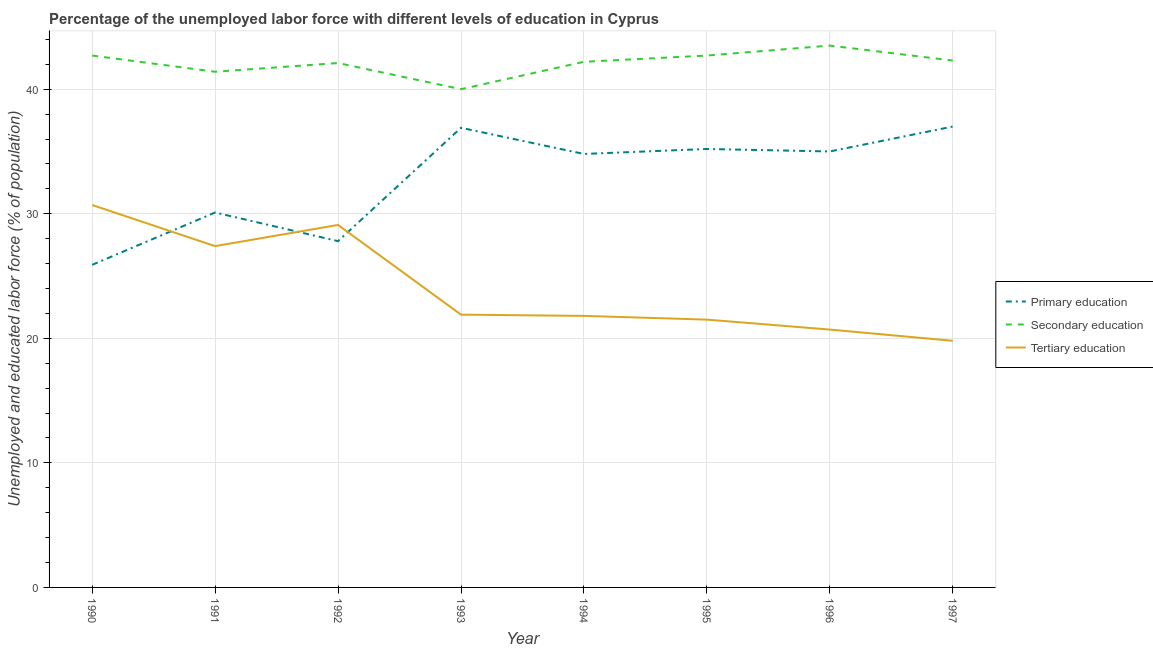Does the line corresponding to percentage of labor force who received primary education intersect with the line corresponding to percentage of labor force who received tertiary education?
Provide a short and direct response. Yes. What is the percentage of labor force who received tertiary education in 1992?
Offer a terse response. 29.1. Across all years, what is the maximum percentage of labor force who received tertiary education?
Your answer should be very brief. 30.7. Across all years, what is the minimum percentage of labor force who received tertiary education?
Provide a short and direct response. 19.8. In which year was the percentage of labor force who received primary education maximum?
Your answer should be compact. 1997. In which year was the percentage of labor force who received secondary education minimum?
Provide a short and direct response. 1993. What is the total percentage of labor force who received secondary education in the graph?
Your response must be concise. 336.9. What is the difference between the percentage of labor force who received primary education in 1993 and that in 1996?
Your answer should be very brief. 1.9. What is the difference between the percentage of labor force who received tertiary education in 1994 and the percentage of labor force who received primary education in 1996?
Offer a very short reply. -13.2. What is the average percentage of labor force who received tertiary education per year?
Provide a short and direct response. 24.11. In the year 1992, what is the difference between the percentage of labor force who received secondary education and percentage of labor force who received tertiary education?
Ensure brevity in your answer.  13. In how many years, is the percentage of labor force who received tertiary education greater than 38 %?
Ensure brevity in your answer.  0. What is the ratio of the percentage of labor force who received secondary education in 1993 to that in 1997?
Offer a terse response. 0.95. Is the difference between the percentage of labor force who received secondary education in 1991 and 1993 greater than the difference between the percentage of labor force who received tertiary education in 1991 and 1993?
Provide a succinct answer. No. What is the difference between the highest and the second highest percentage of labor force who received tertiary education?
Keep it short and to the point. 1.6. What is the difference between the highest and the lowest percentage of labor force who received primary education?
Make the answer very short. 11.1. Is it the case that in every year, the sum of the percentage of labor force who received primary education and percentage of labor force who received secondary education is greater than the percentage of labor force who received tertiary education?
Your answer should be very brief. Yes. Does the percentage of labor force who received primary education monotonically increase over the years?
Keep it short and to the point. No. Is the percentage of labor force who received secondary education strictly less than the percentage of labor force who received primary education over the years?
Your answer should be compact. No. What is the difference between two consecutive major ticks on the Y-axis?
Make the answer very short. 10. Are the values on the major ticks of Y-axis written in scientific E-notation?
Offer a very short reply. No. Does the graph contain any zero values?
Offer a very short reply. No. How many legend labels are there?
Provide a succinct answer. 3. What is the title of the graph?
Your response must be concise. Percentage of the unemployed labor force with different levels of education in Cyprus. Does "Interest" appear as one of the legend labels in the graph?
Give a very brief answer. No. What is the label or title of the Y-axis?
Give a very brief answer. Unemployed and educated labor force (% of population). What is the Unemployed and educated labor force (% of population) of Primary education in 1990?
Keep it short and to the point. 25.9. What is the Unemployed and educated labor force (% of population) of Secondary education in 1990?
Provide a succinct answer. 42.7. What is the Unemployed and educated labor force (% of population) in Tertiary education in 1990?
Ensure brevity in your answer.  30.7. What is the Unemployed and educated labor force (% of population) of Primary education in 1991?
Make the answer very short. 30.1. What is the Unemployed and educated labor force (% of population) of Secondary education in 1991?
Keep it short and to the point. 41.4. What is the Unemployed and educated labor force (% of population) in Tertiary education in 1991?
Offer a very short reply. 27.4. What is the Unemployed and educated labor force (% of population) in Primary education in 1992?
Your answer should be very brief. 27.8. What is the Unemployed and educated labor force (% of population) in Secondary education in 1992?
Provide a succinct answer. 42.1. What is the Unemployed and educated labor force (% of population) of Tertiary education in 1992?
Your answer should be compact. 29.1. What is the Unemployed and educated labor force (% of population) of Primary education in 1993?
Your response must be concise. 36.9. What is the Unemployed and educated labor force (% of population) of Tertiary education in 1993?
Ensure brevity in your answer.  21.9. What is the Unemployed and educated labor force (% of population) in Primary education in 1994?
Offer a terse response. 34.8. What is the Unemployed and educated labor force (% of population) in Secondary education in 1994?
Make the answer very short. 42.2. What is the Unemployed and educated labor force (% of population) of Tertiary education in 1994?
Keep it short and to the point. 21.8. What is the Unemployed and educated labor force (% of population) in Primary education in 1995?
Give a very brief answer. 35.2. What is the Unemployed and educated labor force (% of population) in Secondary education in 1995?
Keep it short and to the point. 42.7. What is the Unemployed and educated labor force (% of population) of Secondary education in 1996?
Ensure brevity in your answer.  43.5. What is the Unemployed and educated labor force (% of population) in Tertiary education in 1996?
Provide a short and direct response. 20.7. What is the Unemployed and educated labor force (% of population) of Secondary education in 1997?
Provide a short and direct response. 42.3. What is the Unemployed and educated labor force (% of population) in Tertiary education in 1997?
Your answer should be very brief. 19.8. Across all years, what is the maximum Unemployed and educated labor force (% of population) of Secondary education?
Offer a very short reply. 43.5. Across all years, what is the maximum Unemployed and educated labor force (% of population) in Tertiary education?
Ensure brevity in your answer.  30.7. Across all years, what is the minimum Unemployed and educated labor force (% of population) of Primary education?
Your answer should be compact. 25.9. Across all years, what is the minimum Unemployed and educated labor force (% of population) of Tertiary education?
Offer a very short reply. 19.8. What is the total Unemployed and educated labor force (% of population) of Primary education in the graph?
Your response must be concise. 262.7. What is the total Unemployed and educated labor force (% of population) in Secondary education in the graph?
Your answer should be compact. 336.9. What is the total Unemployed and educated labor force (% of population) in Tertiary education in the graph?
Keep it short and to the point. 192.9. What is the difference between the Unemployed and educated labor force (% of population) in Secondary education in 1990 and that in 1992?
Offer a terse response. 0.6. What is the difference between the Unemployed and educated labor force (% of population) in Tertiary education in 1990 and that in 1992?
Provide a succinct answer. 1.6. What is the difference between the Unemployed and educated labor force (% of population) in Primary education in 1990 and that in 1995?
Offer a very short reply. -9.3. What is the difference between the Unemployed and educated labor force (% of population) of Primary education in 1990 and that in 1996?
Offer a very short reply. -9.1. What is the difference between the Unemployed and educated labor force (% of population) in Secondary education in 1990 and that in 1996?
Make the answer very short. -0.8. What is the difference between the Unemployed and educated labor force (% of population) in Primary education in 1990 and that in 1997?
Provide a succinct answer. -11.1. What is the difference between the Unemployed and educated labor force (% of population) in Primary education in 1991 and that in 1992?
Ensure brevity in your answer.  2.3. What is the difference between the Unemployed and educated labor force (% of population) in Secondary education in 1991 and that in 1992?
Offer a very short reply. -0.7. What is the difference between the Unemployed and educated labor force (% of population) of Tertiary education in 1991 and that in 1992?
Keep it short and to the point. -1.7. What is the difference between the Unemployed and educated labor force (% of population) in Primary education in 1991 and that in 1993?
Ensure brevity in your answer.  -6.8. What is the difference between the Unemployed and educated labor force (% of population) in Tertiary education in 1991 and that in 1993?
Your answer should be compact. 5.5. What is the difference between the Unemployed and educated labor force (% of population) in Primary education in 1991 and that in 1995?
Give a very brief answer. -5.1. What is the difference between the Unemployed and educated labor force (% of population) in Secondary education in 1991 and that in 1995?
Your answer should be very brief. -1.3. What is the difference between the Unemployed and educated labor force (% of population) in Tertiary education in 1991 and that in 1995?
Keep it short and to the point. 5.9. What is the difference between the Unemployed and educated labor force (% of population) in Tertiary education in 1991 and that in 1996?
Keep it short and to the point. 6.7. What is the difference between the Unemployed and educated labor force (% of population) of Primary education in 1991 and that in 1997?
Provide a short and direct response. -6.9. What is the difference between the Unemployed and educated labor force (% of population) of Tertiary education in 1992 and that in 1993?
Your answer should be compact. 7.2. What is the difference between the Unemployed and educated labor force (% of population) of Primary education in 1992 and that in 1994?
Ensure brevity in your answer.  -7. What is the difference between the Unemployed and educated labor force (% of population) of Secondary education in 1992 and that in 1994?
Your answer should be very brief. -0.1. What is the difference between the Unemployed and educated labor force (% of population) of Tertiary education in 1992 and that in 1994?
Your response must be concise. 7.3. What is the difference between the Unemployed and educated labor force (% of population) of Secondary education in 1992 and that in 1995?
Your response must be concise. -0.6. What is the difference between the Unemployed and educated labor force (% of population) in Tertiary education in 1992 and that in 1995?
Provide a short and direct response. 7.6. What is the difference between the Unemployed and educated labor force (% of population) of Secondary education in 1992 and that in 1996?
Your answer should be compact. -1.4. What is the difference between the Unemployed and educated labor force (% of population) of Primary education in 1992 and that in 1997?
Offer a terse response. -9.2. What is the difference between the Unemployed and educated labor force (% of population) of Secondary education in 1993 and that in 1994?
Offer a terse response. -2.2. What is the difference between the Unemployed and educated labor force (% of population) in Tertiary education in 1993 and that in 1994?
Keep it short and to the point. 0.1. What is the difference between the Unemployed and educated labor force (% of population) in Tertiary education in 1993 and that in 1996?
Provide a short and direct response. 1.2. What is the difference between the Unemployed and educated labor force (% of population) in Tertiary education in 1993 and that in 1997?
Offer a very short reply. 2.1. What is the difference between the Unemployed and educated labor force (% of population) in Primary education in 1994 and that in 1995?
Give a very brief answer. -0.4. What is the difference between the Unemployed and educated labor force (% of population) of Tertiary education in 1994 and that in 1995?
Provide a short and direct response. 0.3. What is the difference between the Unemployed and educated labor force (% of population) of Primary education in 1994 and that in 1997?
Provide a succinct answer. -2.2. What is the difference between the Unemployed and educated labor force (% of population) of Tertiary education in 1994 and that in 1997?
Your answer should be compact. 2. What is the difference between the Unemployed and educated labor force (% of population) in Primary education in 1995 and that in 1996?
Provide a short and direct response. 0.2. What is the difference between the Unemployed and educated labor force (% of population) in Tertiary education in 1995 and that in 1997?
Offer a very short reply. 1.7. What is the difference between the Unemployed and educated labor force (% of population) of Primary education in 1990 and the Unemployed and educated labor force (% of population) of Secondary education in 1991?
Keep it short and to the point. -15.5. What is the difference between the Unemployed and educated labor force (% of population) of Primary education in 1990 and the Unemployed and educated labor force (% of population) of Tertiary education in 1991?
Your response must be concise. -1.5. What is the difference between the Unemployed and educated labor force (% of population) of Primary education in 1990 and the Unemployed and educated labor force (% of population) of Secondary education in 1992?
Give a very brief answer. -16.2. What is the difference between the Unemployed and educated labor force (% of population) of Primary education in 1990 and the Unemployed and educated labor force (% of population) of Tertiary education in 1992?
Keep it short and to the point. -3.2. What is the difference between the Unemployed and educated labor force (% of population) of Secondary education in 1990 and the Unemployed and educated labor force (% of population) of Tertiary education in 1992?
Your answer should be very brief. 13.6. What is the difference between the Unemployed and educated labor force (% of population) of Primary education in 1990 and the Unemployed and educated labor force (% of population) of Secondary education in 1993?
Offer a very short reply. -14.1. What is the difference between the Unemployed and educated labor force (% of population) in Secondary education in 1990 and the Unemployed and educated labor force (% of population) in Tertiary education in 1993?
Your answer should be very brief. 20.8. What is the difference between the Unemployed and educated labor force (% of population) of Primary education in 1990 and the Unemployed and educated labor force (% of population) of Secondary education in 1994?
Your answer should be very brief. -16.3. What is the difference between the Unemployed and educated labor force (% of population) of Secondary education in 1990 and the Unemployed and educated labor force (% of population) of Tertiary education in 1994?
Offer a terse response. 20.9. What is the difference between the Unemployed and educated labor force (% of population) of Primary education in 1990 and the Unemployed and educated labor force (% of population) of Secondary education in 1995?
Give a very brief answer. -16.8. What is the difference between the Unemployed and educated labor force (% of population) in Primary education in 1990 and the Unemployed and educated labor force (% of population) in Tertiary education in 1995?
Keep it short and to the point. 4.4. What is the difference between the Unemployed and educated labor force (% of population) of Secondary education in 1990 and the Unemployed and educated labor force (% of population) of Tertiary education in 1995?
Your answer should be very brief. 21.2. What is the difference between the Unemployed and educated labor force (% of population) of Primary education in 1990 and the Unemployed and educated labor force (% of population) of Secondary education in 1996?
Offer a terse response. -17.6. What is the difference between the Unemployed and educated labor force (% of population) of Primary education in 1990 and the Unemployed and educated labor force (% of population) of Tertiary education in 1996?
Give a very brief answer. 5.2. What is the difference between the Unemployed and educated labor force (% of population) of Secondary education in 1990 and the Unemployed and educated labor force (% of population) of Tertiary education in 1996?
Provide a short and direct response. 22. What is the difference between the Unemployed and educated labor force (% of population) of Primary education in 1990 and the Unemployed and educated labor force (% of population) of Secondary education in 1997?
Keep it short and to the point. -16.4. What is the difference between the Unemployed and educated labor force (% of population) in Primary education in 1990 and the Unemployed and educated labor force (% of population) in Tertiary education in 1997?
Keep it short and to the point. 6.1. What is the difference between the Unemployed and educated labor force (% of population) in Secondary education in 1990 and the Unemployed and educated labor force (% of population) in Tertiary education in 1997?
Provide a short and direct response. 22.9. What is the difference between the Unemployed and educated labor force (% of population) in Primary education in 1991 and the Unemployed and educated labor force (% of population) in Secondary education in 1993?
Your answer should be compact. -9.9. What is the difference between the Unemployed and educated labor force (% of population) of Secondary education in 1991 and the Unemployed and educated labor force (% of population) of Tertiary education in 1993?
Make the answer very short. 19.5. What is the difference between the Unemployed and educated labor force (% of population) of Secondary education in 1991 and the Unemployed and educated labor force (% of population) of Tertiary education in 1994?
Ensure brevity in your answer.  19.6. What is the difference between the Unemployed and educated labor force (% of population) in Primary education in 1991 and the Unemployed and educated labor force (% of population) in Tertiary education in 1995?
Provide a succinct answer. 8.6. What is the difference between the Unemployed and educated labor force (% of population) of Secondary education in 1991 and the Unemployed and educated labor force (% of population) of Tertiary education in 1995?
Your response must be concise. 19.9. What is the difference between the Unemployed and educated labor force (% of population) in Primary education in 1991 and the Unemployed and educated labor force (% of population) in Tertiary education in 1996?
Provide a short and direct response. 9.4. What is the difference between the Unemployed and educated labor force (% of population) of Secondary education in 1991 and the Unemployed and educated labor force (% of population) of Tertiary education in 1996?
Keep it short and to the point. 20.7. What is the difference between the Unemployed and educated labor force (% of population) of Primary education in 1991 and the Unemployed and educated labor force (% of population) of Tertiary education in 1997?
Offer a very short reply. 10.3. What is the difference between the Unemployed and educated labor force (% of population) in Secondary education in 1991 and the Unemployed and educated labor force (% of population) in Tertiary education in 1997?
Your response must be concise. 21.6. What is the difference between the Unemployed and educated labor force (% of population) of Primary education in 1992 and the Unemployed and educated labor force (% of population) of Tertiary education in 1993?
Provide a succinct answer. 5.9. What is the difference between the Unemployed and educated labor force (% of population) in Secondary education in 1992 and the Unemployed and educated labor force (% of population) in Tertiary education in 1993?
Your response must be concise. 20.2. What is the difference between the Unemployed and educated labor force (% of population) in Primary education in 1992 and the Unemployed and educated labor force (% of population) in Secondary education in 1994?
Give a very brief answer. -14.4. What is the difference between the Unemployed and educated labor force (% of population) of Secondary education in 1992 and the Unemployed and educated labor force (% of population) of Tertiary education in 1994?
Provide a short and direct response. 20.3. What is the difference between the Unemployed and educated labor force (% of population) of Primary education in 1992 and the Unemployed and educated labor force (% of population) of Secondary education in 1995?
Give a very brief answer. -14.9. What is the difference between the Unemployed and educated labor force (% of population) of Primary education in 1992 and the Unemployed and educated labor force (% of population) of Tertiary education in 1995?
Your answer should be very brief. 6.3. What is the difference between the Unemployed and educated labor force (% of population) of Secondary education in 1992 and the Unemployed and educated labor force (% of population) of Tertiary education in 1995?
Offer a very short reply. 20.6. What is the difference between the Unemployed and educated labor force (% of population) in Primary education in 1992 and the Unemployed and educated labor force (% of population) in Secondary education in 1996?
Give a very brief answer. -15.7. What is the difference between the Unemployed and educated labor force (% of population) in Primary education in 1992 and the Unemployed and educated labor force (% of population) in Tertiary education in 1996?
Ensure brevity in your answer.  7.1. What is the difference between the Unemployed and educated labor force (% of population) in Secondary education in 1992 and the Unemployed and educated labor force (% of population) in Tertiary education in 1996?
Ensure brevity in your answer.  21.4. What is the difference between the Unemployed and educated labor force (% of population) of Primary education in 1992 and the Unemployed and educated labor force (% of population) of Tertiary education in 1997?
Keep it short and to the point. 8. What is the difference between the Unemployed and educated labor force (% of population) in Secondary education in 1992 and the Unemployed and educated labor force (% of population) in Tertiary education in 1997?
Keep it short and to the point. 22.3. What is the difference between the Unemployed and educated labor force (% of population) in Primary education in 1993 and the Unemployed and educated labor force (% of population) in Secondary education in 1994?
Give a very brief answer. -5.3. What is the difference between the Unemployed and educated labor force (% of population) of Secondary education in 1993 and the Unemployed and educated labor force (% of population) of Tertiary education in 1994?
Keep it short and to the point. 18.2. What is the difference between the Unemployed and educated labor force (% of population) in Primary education in 1993 and the Unemployed and educated labor force (% of population) in Tertiary education in 1996?
Your response must be concise. 16.2. What is the difference between the Unemployed and educated labor force (% of population) in Secondary education in 1993 and the Unemployed and educated labor force (% of population) in Tertiary education in 1996?
Ensure brevity in your answer.  19.3. What is the difference between the Unemployed and educated labor force (% of population) of Primary education in 1993 and the Unemployed and educated labor force (% of population) of Secondary education in 1997?
Offer a very short reply. -5.4. What is the difference between the Unemployed and educated labor force (% of population) in Primary education in 1993 and the Unemployed and educated labor force (% of population) in Tertiary education in 1997?
Give a very brief answer. 17.1. What is the difference between the Unemployed and educated labor force (% of population) of Secondary education in 1993 and the Unemployed and educated labor force (% of population) of Tertiary education in 1997?
Provide a succinct answer. 20.2. What is the difference between the Unemployed and educated labor force (% of population) of Secondary education in 1994 and the Unemployed and educated labor force (% of population) of Tertiary education in 1995?
Give a very brief answer. 20.7. What is the difference between the Unemployed and educated labor force (% of population) of Primary education in 1994 and the Unemployed and educated labor force (% of population) of Secondary education in 1997?
Provide a succinct answer. -7.5. What is the difference between the Unemployed and educated labor force (% of population) in Primary education in 1994 and the Unemployed and educated labor force (% of population) in Tertiary education in 1997?
Give a very brief answer. 15. What is the difference between the Unemployed and educated labor force (% of population) of Secondary education in 1994 and the Unemployed and educated labor force (% of population) of Tertiary education in 1997?
Your response must be concise. 22.4. What is the difference between the Unemployed and educated labor force (% of population) of Primary education in 1995 and the Unemployed and educated labor force (% of population) of Secondary education in 1996?
Your response must be concise. -8.3. What is the difference between the Unemployed and educated labor force (% of population) in Secondary education in 1995 and the Unemployed and educated labor force (% of population) in Tertiary education in 1996?
Keep it short and to the point. 22. What is the difference between the Unemployed and educated labor force (% of population) in Primary education in 1995 and the Unemployed and educated labor force (% of population) in Tertiary education in 1997?
Give a very brief answer. 15.4. What is the difference between the Unemployed and educated labor force (% of population) of Secondary education in 1995 and the Unemployed and educated labor force (% of population) of Tertiary education in 1997?
Your answer should be compact. 22.9. What is the difference between the Unemployed and educated labor force (% of population) of Primary education in 1996 and the Unemployed and educated labor force (% of population) of Secondary education in 1997?
Offer a terse response. -7.3. What is the difference between the Unemployed and educated labor force (% of population) of Primary education in 1996 and the Unemployed and educated labor force (% of population) of Tertiary education in 1997?
Provide a short and direct response. 15.2. What is the difference between the Unemployed and educated labor force (% of population) of Secondary education in 1996 and the Unemployed and educated labor force (% of population) of Tertiary education in 1997?
Make the answer very short. 23.7. What is the average Unemployed and educated labor force (% of population) in Primary education per year?
Offer a terse response. 32.84. What is the average Unemployed and educated labor force (% of population) of Secondary education per year?
Provide a short and direct response. 42.11. What is the average Unemployed and educated labor force (% of population) in Tertiary education per year?
Your answer should be very brief. 24.11. In the year 1990, what is the difference between the Unemployed and educated labor force (% of population) in Primary education and Unemployed and educated labor force (% of population) in Secondary education?
Provide a succinct answer. -16.8. In the year 1991, what is the difference between the Unemployed and educated labor force (% of population) in Primary education and Unemployed and educated labor force (% of population) in Secondary education?
Provide a succinct answer. -11.3. In the year 1991, what is the difference between the Unemployed and educated labor force (% of population) of Primary education and Unemployed and educated labor force (% of population) of Tertiary education?
Your response must be concise. 2.7. In the year 1991, what is the difference between the Unemployed and educated labor force (% of population) in Secondary education and Unemployed and educated labor force (% of population) in Tertiary education?
Make the answer very short. 14. In the year 1992, what is the difference between the Unemployed and educated labor force (% of population) in Primary education and Unemployed and educated labor force (% of population) in Secondary education?
Make the answer very short. -14.3. In the year 1992, what is the difference between the Unemployed and educated labor force (% of population) in Secondary education and Unemployed and educated labor force (% of population) in Tertiary education?
Your answer should be very brief. 13. In the year 1994, what is the difference between the Unemployed and educated labor force (% of population) in Primary education and Unemployed and educated labor force (% of population) in Tertiary education?
Offer a terse response. 13. In the year 1994, what is the difference between the Unemployed and educated labor force (% of population) in Secondary education and Unemployed and educated labor force (% of population) in Tertiary education?
Provide a short and direct response. 20.4. In the year 1995, what is the difference between the Unemployed and educated labor force (% of population) in Primary education and Unemployed and educated labor force (% of population) in Tertiary education?
Offer a very short reply. 13.7. In the year 1995, what is the difference between the Unemployed and educated labor force (% of population) of Secondary education and Unemployed and educated labor force (% of population) of Tertiary education?
Provide a short and direct response. 21.2. In the year 1996, what is the difference between the Unemployed and educated labor force (% of population) in Primary education and Unemployed and educated labor force (% of population) in Tertiary education?
Ensure brevity in your answer.  14.3. In the year 1996, what is the difference between the Unemployed and educated labor force (% of population) in Secondary education and Unemployed and educated labor force (% of population) in Tertiary education?
Your answer should be very brief. 22.8. In the year 1997, what is the difference between the Unemployed and educated labor force (% of population) in Primary education and Unemployed and educated labor force (% of population) in Tertiary education?
Your answer should be compact. 17.2. In the year 1997, what is the difference between the Unemployed and educated labor force (% of population) in Secondary education and Unemployed and educated labor force (% of population) in Tertiary education?
Provide a short and direct response. 22.5. What is the ratio of the Unemployed and educated labor force (% of population) in Primary education in 1990 to that in 1991?
Provide a short and direct response. 0.86. What is the ratio of the Unemployed and educated labor force (% of population) in Secondary education in 1990 to that in 1991?
Make the answer very short. 1.03. What is the ratio of the Unemployed and educated labor force (% of population) in Tertiary education in 1990 to that in 1991?
Offer a terse response. 1.12. What is the ratio of the Unemployed and educated labor force (% of population) of Primary education in 1990 to that in 1992?
Give a very brief answer. 0.93. What is the ratio of the Unemployed and educated labor force (% of population) of Secondary education in 1990 to that in 1992?
Make the answer very short. 1.01. What is the ratio of the Unemployed and educated labor force (% of population) in Tertiary education in 1990 to that in 1992?
Offer a terse response. 1.05. What is the ratio of the Unemployed and educated labor force (% of population) of Primary education in 1990 to that in 1993?
Your answer should be compact. 0.7. What is the ratio of the Unemployed and educated labor force (% of population) in Secondary education in 1990 to that in 1993?
Provide a short and direct response. 1.07. What is the ratio of the Unemployed and educated labor force (% of population) in Tertiary education in 1990 to that in 1993?
Provide a short and direct response. 1.4. What is the ratio of the Unemployed and educated labor force (% of population) of Primary education in 1990 to that in 1994?
Keep it short and to the point. 0.74. What is the ratio of the Unemployed and educated labor force (% of population) in Secondary education in 1990 to that in 1994?
Make the answer very short. 1.01. What is the ratio of the Unemployed and educated labor force (% of population) in Tertiary education in 1990 to that in 1994?
Provide a succinct answer. 1.41. What is the ratio of the Unemployed and educated labor force (% of population) of Primary education in 1990 to that in 1995?
Offer a very short reply. 0.74. What is the ratio of the Unemployed and educated labor force (% of population) of Tertiary education in 1990 to that in 1995?
Your answer should be very brief. 1.43. What is the ratio of the Unemployed and educated labor force (% of population) of Primary education in 1990 to that in 1996?
Provide a short and direct response. 0.74. What is the ratio of the Unemployed and educated labor force (% of population) in Secondary education in 1990 to that in 1996?
Your response must be concise. 0.98. What is the ratio of the Unemployed and educated labor force (% of population) of Tertiary education in 1990 to that in 1996?
Your answer should be very brief. 1.48. What is the ratio of the Unemployed and educated labor force (% of population) in Primary education in 1990 to that in 1997?
Make the answer very short. 0.7. What is the ratio of the Unemployed and educated labor force (% of population) of Secondary education in 1990 to that in 1997?
Keep it short and to the point. 1.01. What is the ratio of the Unemployed and educated labor force (% of population) in Tertiary education in 1990 to that in 1997?
Keep it short and to the point. 1.55. What is the ratio of the Unemployed and educated labor force (% of population) of Primary education in 1991 to that in 1992?
Offer a terse response. 1.08. What is the ratio of the Unemployed and educated labor force (% of population) in Secondary education in 1991 to that in 1992?
Offer a very short reply. 0.98. What is the ratio of the Unemployed and educated labor force (% of population) in Tertiary education in 1991 to that in 1992?
Provide a succinct answer. 0.94. What is the ratio of the Unemployed and educated labor force (% of population) in Primary education in 1991 to that in 1993?
Provide a short and direct response. 0.82. What is the ratio of the Unemployed and educated labor force (% of population) of Secondary education in 1991 to that in 1993?
Your answer should be compact. 1.03. What is the ratio of the Unemployed and educated labor force (% of population) of Tertiary education in 1991 to that in 1993?
Your response must be concise. 1.25. What is the ratio of the Unemployed and educated labor force (% of population) in Primary education in 1991 to that in 1994?
Keep it short and to the point. 0.86. What is the ratio of the Unemployed and educated labor force (% of population) of Secondary education in 1991 to that in 1994?
Your answer should be compact. 0.98. What is the ratio of the Unemployed and educated labor force (% of population) in Tertiary education in 1991 to that in 1994?
Keep it short and to the point. 1.26. What is the ratio of the Unemployed and educated labor force (% of population) of Primary education in 1991 to that in 1995?
Offer a terse response. 0.86. What is the ratio of the Unemployed and educated labor force (% of population) in Secondary education in 1991 to that in 1995?
Offer a terse response. 0.97. What is the ratio of the Unemployed and educated labor force (% of population) of Tertiary education in 1991 to that in 1995?
Provide a succinct answer. 1.27. What is the ratio of the Unemployed and educated labor force (% of population) in Primary education in 1991 to that in 1996?
Provide a short and direct response. 0.86. What is the ratio of the Unemployed and educated labor force (% of population) in Secondary education in 1991 to that in 1996?
Keep it short and to the point. 0.95. What is the ratio of the Unemployed and educated labor force (% of population) in Tertiary education in 1991 to that in 1996?
Provide a succinct answer. 1.32. What is the ratio of the Unemployed and educated labor force (% of population) in Primary education in 1991 to that in 1997?
Keep it short and to the point. 0.81. What is the ratio of the Unemployed and educated labor force (% of population) of Secondary education in 1991 to that in 1997?
Ensure brevity in your answer.  0.98. What is the ratio of the Unemployed and educated labor force (% of population) in Tertiary education in 1991 to that in 1997?
Offer a terse response. 1.38. What is the ratio of the Unemployed and educated labor force (% of population) in Primary education in 1992 to that in 1993?
Offer a very short reply. 0.75. What is the ratio of the Unemployed and educated labor force (% of population) of Secondary education in 1992 to that in 1993?
Give a very brief answer. 1.05. What is the ratio of the Unemployed and educated labor force (% of population) of Tertiary education in 1992 to that in 1993?
Ensure brevity in your answer.  1.33. What is the ratio of the Unemployed and educated labor force (% of population) of Primary education in 1992 to that in 1994?
Provide a short and direct response. 0.8. What is the ratio of the Unemployed and educated labor force (% of population) of Tertiary education in 1992 to that in 1994?
Your answer should be very brief. 1.33. What is the ratio of the Unemployed and educated labor force (% of population) in Primary education in 1992 to that in 1995?
Keep it short and to the point. 0.79. What is the ratio of the Unemployed and educated labor force (% of population) of Secondary education in 1992 to that in 1995?
Make the answer very short. 0.99. What is the ratio of the Unemployed and educated labor force (% of population) in Tertiary education in 1992 to that in 1995?
Offer a terse response. 1.35. What is the ratio of the Unemployed and educated labor force (% of population) of Primary education in 1992 to that in 1996?
Make the answer very short. 0.79. What is the ratio of the Unemployed and educated labor force (% of population) of Secondary education in 1992 to that in 1996?
Provide a short and direct response. 0.97. What is the ratio of the Unemployed and educated labor force (% of population) in Tertiary education in 1992 to that in 1996?
Offer a terse response. 1.41. What is the ratio of the Unemployed and educated labor force (% of population) in Primary education in 1992 to that in 1997?
Give a very brief answer. 0.75. What is the ratio of the Unemployed and educated labor force (% of population) of Secondary education in 1992 to that in 1997?
Give a very brief answer. 1. What is the ratio of the Unemployed and educated labor force (% of population) in Tertiary education in 1992 to that in 1997?
Your response must be concise. 1.47. What is the ratio of the Unemployed and educated labor force (% of population) in Primary education in 1993 to that in 1994?
Offer a very short reply. 1.06. What is the ratio of the Unemployed and educated labor force (% of population) of Secondary education in 1993 to that in 1994?
Your answer should be compact. 0.95. What is the ratio of the Unemployed and educated labor force (% of population) in Tertiary education in 1993 to that in 1994?
Make the answer very short. 1. What is the ratio of the Unemployed and educated labor force (% of population) of Primary education in 1993 to that in 1995?
Make the answer very short. 1.05. What is the ratio of the Unemployed and educated labor force (% of population) of Secondary education in 1993 to that in 1995?
Offer a very short reply. 0.94. What is the ratio of the Unemployed and educated labor force (% of population) of Tertiary education in 1993 to that in 1995?
Keep it short and to the point. 1.02. What is the ratio of the Unemployed and educated labor force (% of population) of Primary education in 1993 to that in 1996?
Offer a terse response. 1.05. What is the ratio of the Unemployed and educated labor force (% of population) of Secondary education in 1993 to that in 1996?
Offer a very short reply. 0.92. What is the ratio of the Unemployed and educated labor force (% of population) of Tertiary education in 1993 to that in 1996?
Provide a short and direct response. 1.06. What is the ratio of the Unemployed and educated labor force (% of population) of Secondary education in 1993 to that in 1997?
Offer a very short reply. 0.95. What is the ratio of the Unemployed and educated labor force (% of population) in Tertiary education in 1993 to that in 1997?
Ensure brevity in your answer.  1.11. What is the ratio of the Unemployed and educated labor force (% of population) in Primary education in 1994 to that in 1995?
Provide a short and direct response. 0.99. What is the ratio of the Unemployed and educated labor force (% of population) in Secondary education in 1994 to that in 1995?
Your answer should be very brief. 0.99. What is the ratio of the Unemployed and educated labor force (% of population) in Tertiary education in 1994 to that in 1995?
Provide a succinct answer. 1.01. What is the ratio of the Unemployed and educated labor force (% of population) of Primary education in 1994 to that in 1996?
Your answer should be compact. 0.99. What is the ratio of the Unemployed and educated labor force (% of population) in Secondary education in 1994 to that in 1996?
Your answer should be very brief. 0.97. What is the ratio of the Unemployed and educated labor force (% of population) of Tertiary education in 1994 to that in 1996?
Your answer should be compact. 1.05. What is the ratio of the Unemployed and educated labor force (% of population) in Primary education in 1994 to that in 1997?
Your response must be concise. 0.94. What is the ratio of the Unemployed and educated labor force (% of population) in Secondary education in 1994 to that in 1997?
Make the answer very short. 1. What is the ratio of the Unemployed and educated labor force (% of population) of Tertiary education in 1994 to that in 1997?
Your response must be concise. 1.1. What is the ratio of the Unemployed and educated labor force (% of population) of Primary education in 1995 to that in 1996?
Your answer should be very brief. 1.01. What is the ratio of the Unemployed and educated labor force (% of population) in Secondary education in 1995 to that in 1996?
Offer a terse response. 0.98. What is the ratio of the Unemployed and educated labor force (% of population) in Tertiary education in 1995 to that in 1996?
Ensure brevity in your answer.  1.04. What is the ratio of the Unemployed and educated labor force (% of population) in Primary education in 1995 to that in 1997?
Provide a short and direct response. 0.95. What is the ratio of the Unemployed and educated labor force (% of population) of Secondary education in 1995 to that in 1997?
Provide a short and direct response. 1.01. What is the ratio of the Unemployed and educated labor force (% of population) of Tertiary education in 1995 to that in 1997?
Your answer should be compact. 1.09. What is the ratio of the Unemployed and educated labor force (% of population) in Primary education in 1996 to that in 1997?
Give a very brief answer. 0.95. What is the ratio of the Unemployed and educated labor force (% of population) of Secondary education in 1996 to that in 1997?
Your answer should be very brief. 1.03. What is the ratio of the Unemployed and educated labor force (% of population) in Tertiary education in 1996 to that in 1997?
Ensure brevity in your answer.  1.05. What is the difference between the highest and the second highest Unemployed and educated labor force (% of population) in Primary education?
Your answer should be very brief. 0.1. What is the difference between the highest and the second highest Unemployed and educated labor force (% of population) in Secondary education?
Make the answer very short. 0.8. What is the difference between the highest and the lowest Unemployed and educated labor force (% of population) in Primary education?
Provide a succinct answer. 11.1. What is the difference between the highest and the lowest Unemployed and educated labor force (% of population) of Tertiary education?
Give a very brief answer. 10.9. 